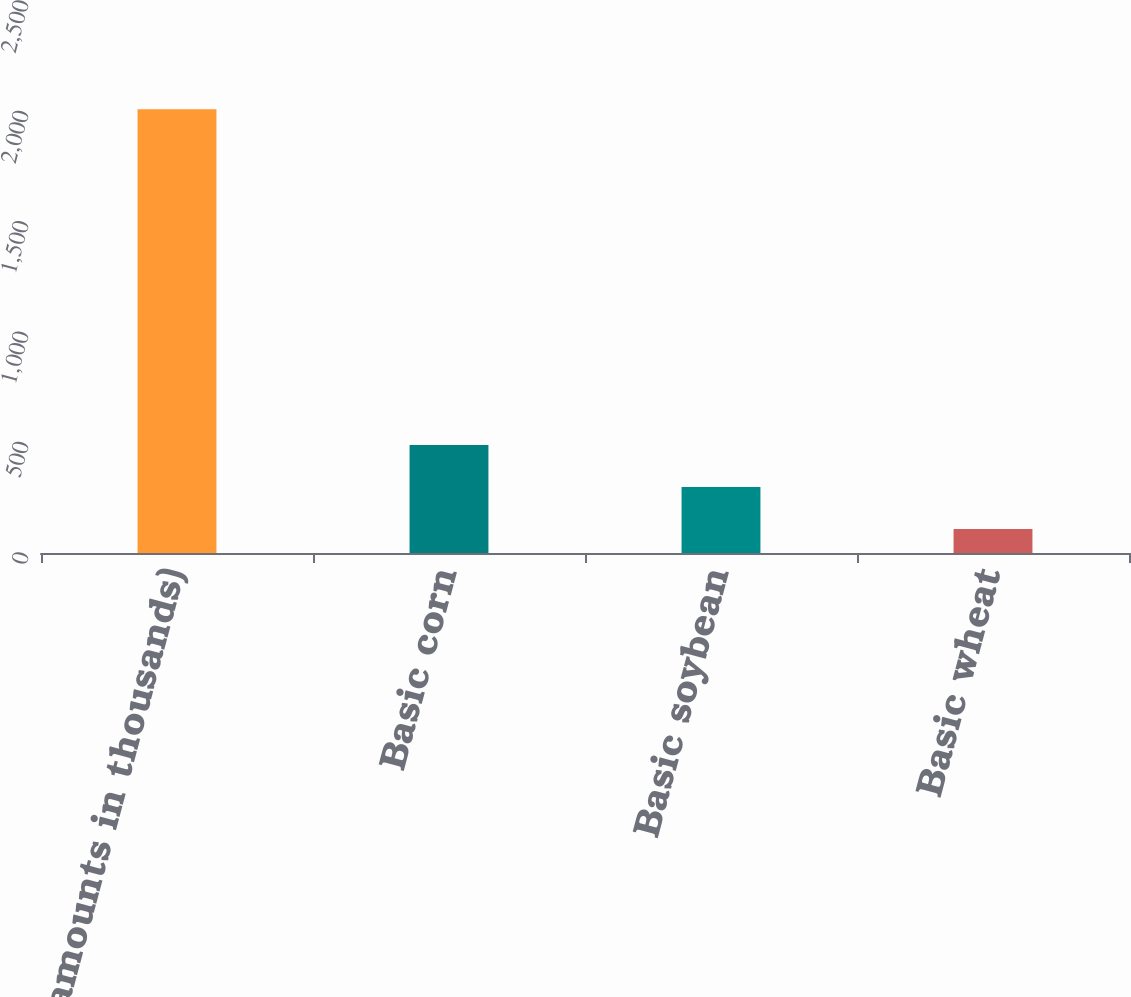Convert chart to OTSL. <chart><loc_0><loc_0><loc_500><loc_500><bar_chart><fcel>(amounts in thousands)<fcel>Basic corn<fcel>Basic soybean<fcel>Basic wheat<nl><fcel>2010<fcel>489.2<fcel>299.1<fcel>109<nl></chart> 